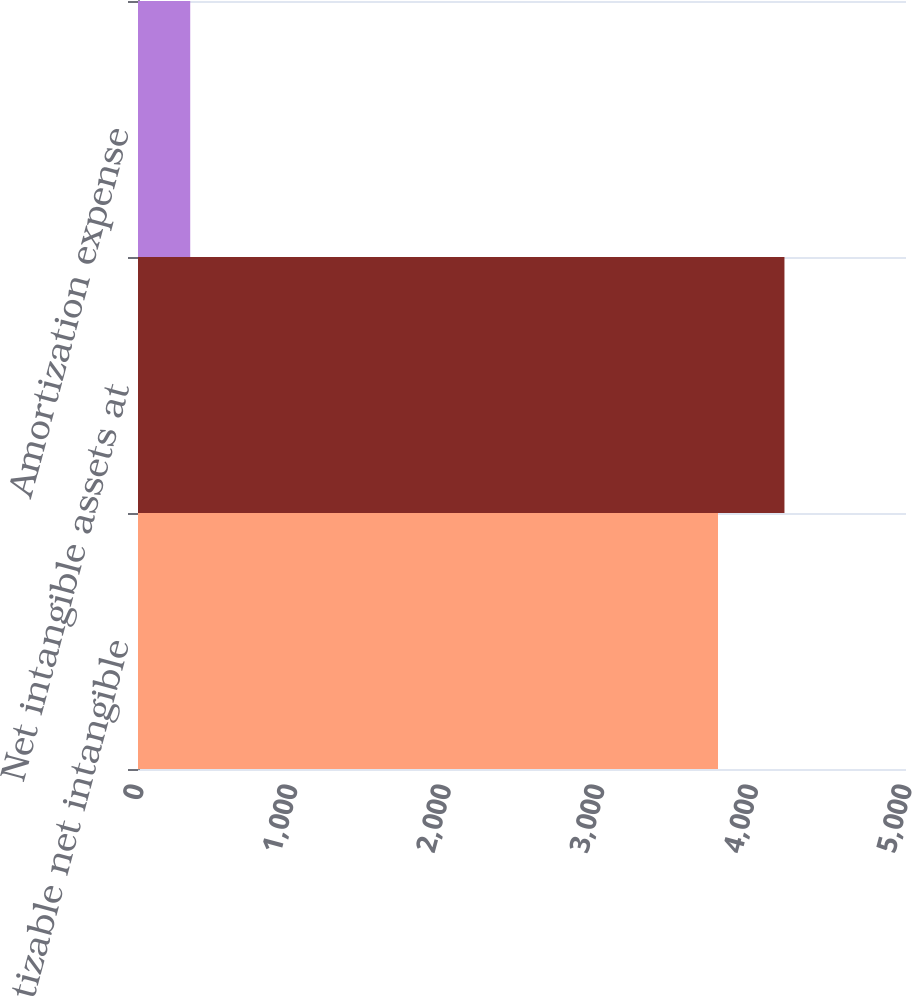Convert chart to OTSL. <chart><loc_0><loc_0><loc_500><loc_500><bar_chart><fcel>Amortizable net intangible<fcel>Net intangible assets at<fcel>Amortization expense<nl><fcel>3776<fcel>4208.7<fcel>340<nl></chart> 